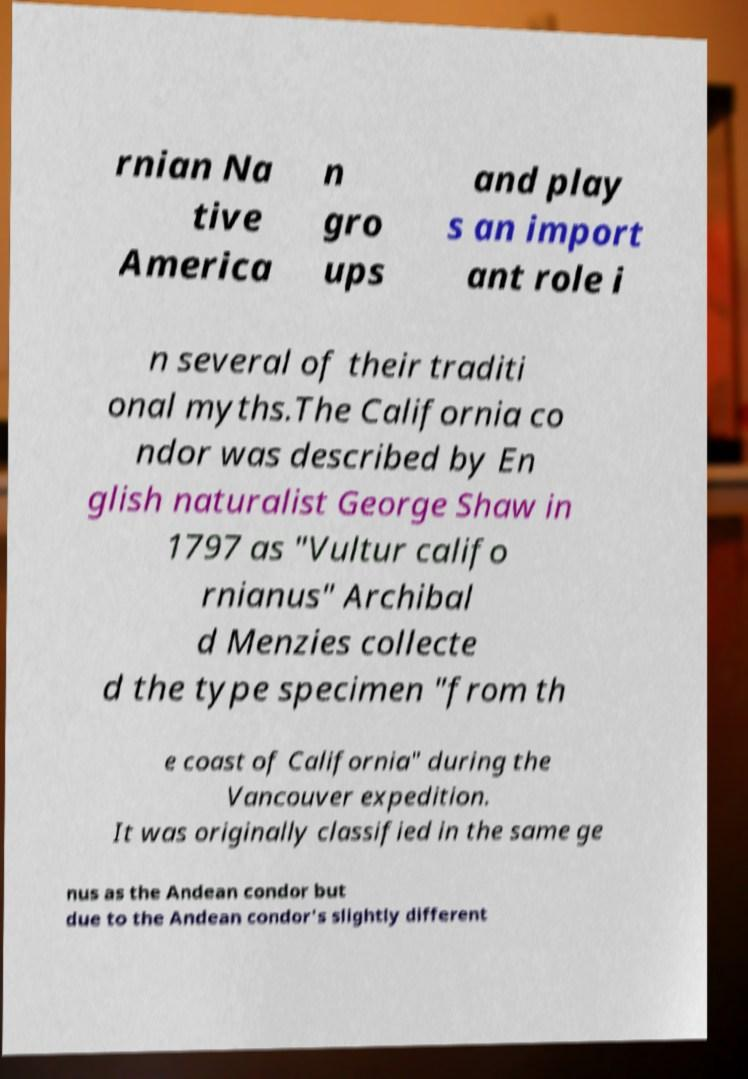Can you read and provide the text displayed in the image?This photo seems to have some interesting text. Can you extract and type it out for me? rnian Na tive America n gro ups and play s an import ant role i n several of their traditi onal myths.The California co ndor was described by En glish naturalist George Shaw in 1797 as "Vultur califo rnianus" Archibal d Menzies collecte d the type specimen "from th e coast of California" during the Vancouver expedition. It was originally classified in the same ge nus as the Andean condor but due to the Andean condor's slightly different 